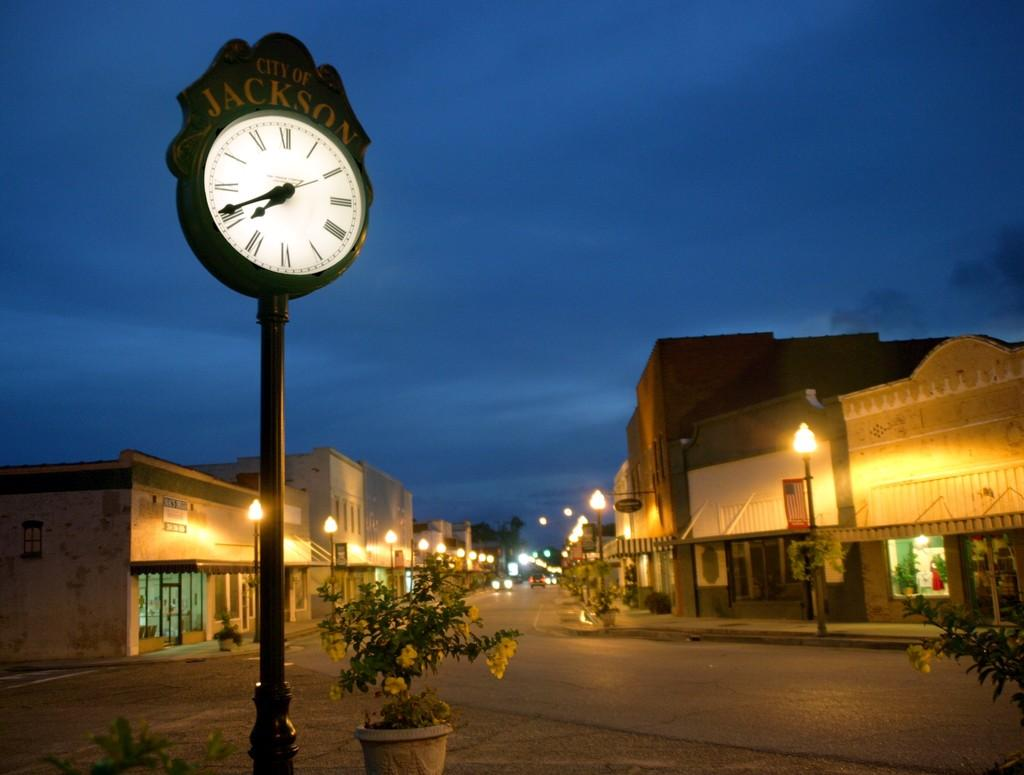<image>
Render a clear and concise summary of the photo. A clock in the City of Jackson is lit up at night so people can see what time it is. 